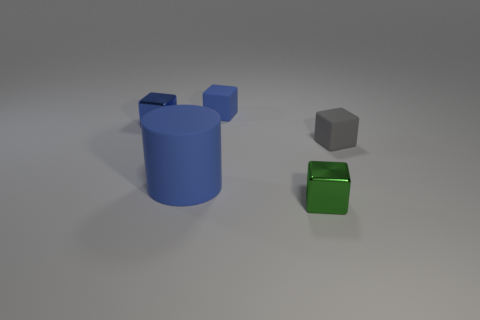What can you infer about the lighting and texture of the objects? The lighting in the image appears to be diffused and coming from above, creating soft shadows on the ground. The texture of the objects is matte, with the blue cylinder having a slightly reflective surface, adding a touch of realism to the scene. 